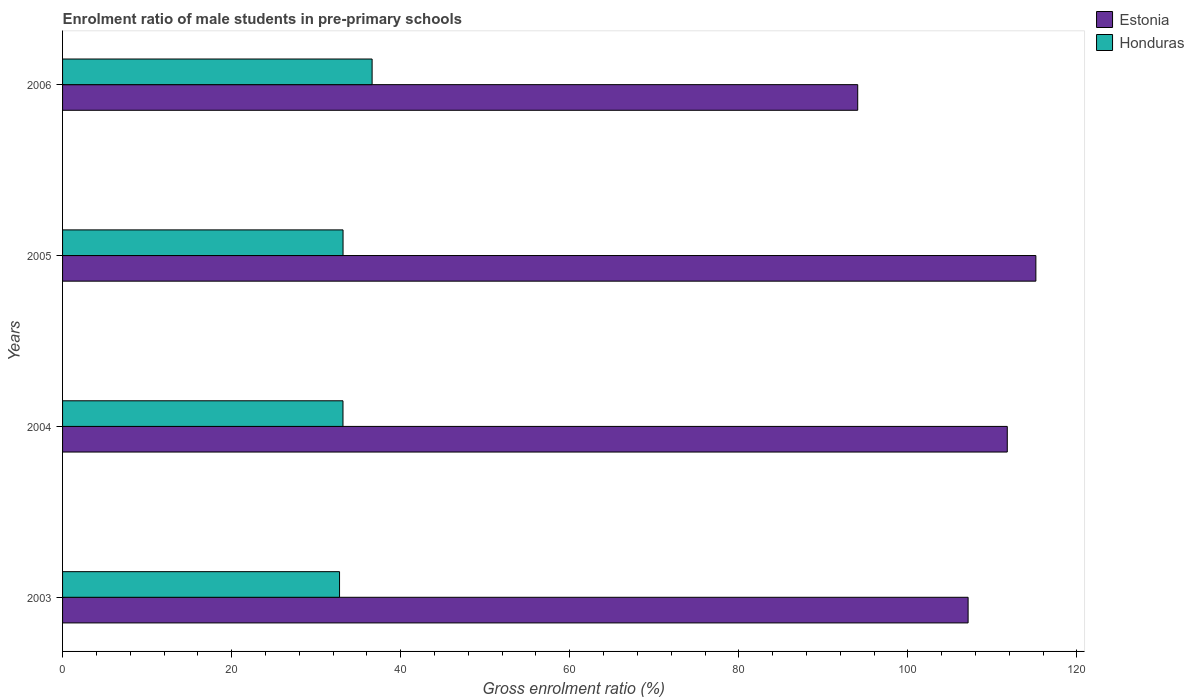How many bars are there on the 3rd tick from the top?
Offer a terse response. 2. What is the label of the 2nd group of bars from the top?
Your answer should be very brief. 2005. What is the enrolment ratio of male students in pre-primary schools in Honduras in 2003?
Make the answer very short. 32.77. Across all years, what is the maximum enrolment ratio of male students in pre-primary schools in Estonia?
Your answer should be compact. 115.14. Across all years, what is the minimum enrolment ratio of male students in pre-primary schools in Estonia?
Provide a succinct answer. 94.06. In which year was the enrolment ratio of male students in pre-primary schools in Honduras minimum?
Ensure brevity in your answer.  2003. What is the total enrolment ratio of male students in pre-primary schools in Estonia in the graph?
Your answer should be very brief. 428.08. What is the difference between the enrolment ratio of male students in pre-primary schools in Honduras in 2003 and that in 2006?
Provide a short and direct response. -3.85. What is the difference between the enrolment ratio of male students in pre-primary schools in Estonia in 2004 and the enrolment ratio of male students in pre-primary schools in Honduras in 2005?
Give a very brief answer. 78.58. What is the average enrolment ratio of male students in pre-primary schools in Estonia per year?
Your answer should be very brief. 107.02. In the year 2006, what is the difference between the enrolment ratio of male students in pre-primary schools in Estonia and enrolment ratio of male students in pre-primary schools in Honduras?
Your answer should be very brief. 57.45. In how many years, is the enrolment ratio of male students in pre-primary schools in Estonia greater than 52 %?
Keep it short and to the point. 4. What is the ratio of the enrolment ratio of male students in pre-primary schools in Estonia in 2005 to that in 2006?
Ensure brevity in your answer.  1.22. What is the difference between the highest and the second highest enrolment ratio of male students in pre-primary schools in Honduras?
Your answer should be very brief. 3.44. What is the difference between the highest and the lowest enrolment ratio of male students in pre-primary schools in Honduras?
Provide a succinct answer. 3.85. In how many years, is the enrolment ratio of male students in pre-primary schools in Honduras greater than the average enrolment ratio of male students in pre-primary schools in Honduras taken over all years?
Make the answer very short. 1. What does the 1st bar from the top in 2006 represents?
Your answer should be compact. Honduras. What does the 1st bar from the bottom in 2005 represents?
Keep it short and to the point. Estonia. How many bars are there?
Your answer should be very brief. 8. Are all the bars in the graph horizontal?
Give a very brief answer. Yes. How many years are there in the graph?
Give a very brief answer. 4. What is the difference between two consecutive major ticks on the X-axis?
Your answer should be compact. 20. Does the graph contain any zero values?
Provide a short and direct response. No. Does the graph contain grids?
Make the answer very short. No. How are the legend labels stacked?
Make the answer very short. Vertical. What is the title of the graph?
Offer a very short reply. Enrolment ratio of male students in pre-primary schools. Does "Antigua and Barbuda" appear as one of the legend labels in the graph?
Ensure brevity in your answer.  No. What is the Gross enrolment ratio (%) in Estonia in 2003?
Give a very brief answer. 107.12. What is the Gross enrolment ratio (%) in Honduras in 2003?
Your answer should be very brief. 32.77. What is the Gross enrolment ratio (%) in Estonia in 2004?
Offer a terse response. 111.76. What is the Gross enrolment ratio (%) of Honduras in 2004?
Offer a very short reply. 33.17. What is the Gross enrolment ratio (%) of Estonia in 2005?
Keep it short and to the point. 115.14. What is the Gross enrolment ratio (%) in Honduras in 2005?
Give a very brief answer. 33.18. What is the Gross enrolment ratio (%) of Estonia in 2006?
Offer a very short reply. 94.06. What is the Gross enrolment ratio (%) of Honduras in 2006?
Your response must be concise. 36.62. Across all years, what is the maximum Gross enrolment ratio (%) of Estonia?
Your answer should be very brief. 115.14. Across all years, what is the maximum Gross enrolment ratio (%) in Honduras?
Provide a short and direct response. 36.62. Across all years, what is the minimum Gross enrolment ratio (%) of Estonia?
Offer a terse response. 94.06. Across all years, what is the minimum Gross enrolment ratio (%) in Honduras?
Offer a terse response. 32.77. What is the total Gross enrolment ratio (%) of Estonia in the graph?
Make the answer very short. 428.08. What is the total Gross enrolment ratio (%) of Honduras in the graph?
Provide a short and direct response. 135.74. What is the difference between the Gross enrolment ratio (%) in Estonia in 2003 and that in 2004?
Keep it short and to the point. -4.63. What is the difference between the Gross enrolment ratio (%) of Honduras in 2003 and that in 2004?
Your answer should be very brief. -0.41. What is the difference between the Gross enrolment ratio (%) of Estonia in 2003 and that in 2005?
Provide a succinct answer. -8.02. What is the difference between the Gross enrolment ratio (%) in Honduras in 2003 and that in 2005?
Ensure brevity in your answer.  -0.41. What is the difference between the Gross enrolment ratio (%) in Estonia in 2003 and that in 2006?
Provide a succinct answer. 13.06. What is the difference between the Gross enrolment ratio (%) in Honduras in 2003 and that in 2006?
Keep it short and to the point. -3.85. What is the difference between the Gross enrolment ratio (%) of Estonia in 2004 and that in 2005?
Give a very brief answer. -3.38. What is the difference between the Gross enrolment ratio (%) of Honduras in 2004 and that in 2005?
Offer a terse response. -0.01. What is the difference between the Gross enrolment ratio (%) in Estonia in 2004 and that in 2006?
Provide a succinct answer. 17.69. What is the difference between the Gross enrolment ratio (%) of Honduras in 2004 and that in 2006?
Give a very brief answer. -3.45. What is the difference between the Gross enrolment ratio (%) in Estonia in 2005 and that in 2006?
Provide a succinct answer. 21.07. What is the difference between the Gross enrolment ratio (%) in Honduras in 2005 and that in 2006?
Keep it short and to the point. -3.44. What is the difference between the Gross enrolment ratio (%) of Estonia in 2003 and the Gross enrolment ratio (%) of Honduras in 2004?
Give a very brief answer. 73.95. What is the difference between the Gross enrolment ratio (%) of Estonia in 2003 and the Gross enrolment ratio (%) of Honduras in 2005?
Provide a succinct answer. 73.94. What is the difference between the Gross enrolment ratio (%) in Estonia in 2003 and the Gross enrolment ratio (%) in Honduras in 2006?
Your answer should be very brief. 70.5. What is the difference between the Gross enrolment ratio (%) of Estonia in 2004 and the Gross enrolment ratio (%) of Honduras in 2005?
Your answer should be very brief. 78.58. What is the difference between the Gross enrolment ratio (%) of Estonia in 2004 and the Gross enrolment ratio (%) of Honduras in 2006?
Provide a succinct answer. 75.14. What is the difference between the Gross enrolment ratio (%) of Estonia in 2005 and the Gross enrolment ratio (%) of Honduras in 2006?
Your answer should be compact. 78.52. What is the average Gross enrolment ratio (%) of Estonia per year?
Give a very brief answer. 107.02. What is the average Gross enrolment ratio (%) of Honduras per year?
Keep it short and to the point. 33.93. In the year 2003, what is the difference between the Gross enrolment ratio (%) in Estonia and Gross enrolment ratio (%) in Honduras?
Your answer should be compact. 74.36. In the year 2004, what is the difference between the Gross enrolment ratio (%) in Estonia and Gross enrolment ratio (%) in Honduras?
Your answer should be very brief. 78.58. In the year 2005, what is the difference between the Gross enrolment ratio (%) of Estonia and Gross enrolment ratio (%) of Honduras?
Provide a succinct answer. 81.96. In the year 2006, what is the difference between the Gross enrolment ratio (%) of Estonia and Gross enrolment ratio (%) of Honduras?
Your response must be concise. 57.45. What is the ratio of the Gross enrolment ratio (%) of Estonia in 2003 to that in 2004?
Your answer should be very brief. 0.96. What is the ratio of the Gross enrolment ratio (%) in Estonia in 2003 to that in 2005?
Your response must be concise. 0.93. What is the ratio of the Gross enrolment ratio (%) of Honduras in 2003 to that in 2005?
Offer a very short reply. 0.99. What is the ratio of the Gross enrolment ratio (%) of Estonia in 2003 to that in 2006?
Your response must be concise. 1.14. What is the ratio of the Gross enrolment ratio (%) in Honduras in 2003 to that in 2006?
Your response must be concise. 0.89. What is the ratio of the Gross enrolment ratio (%) of Estonia in 2004 to that in 2005?
Your answer should be compact. 0.97. What is the ratio of the Gross enrolment ratio (%) in Honduras in 2004 to that in 2005?
Offer a very short reply. 1. What is the ratio of the Gross enrolment ratio (%) in Estonia in 2004 to that in 2006?
Offer a terse response. 1.19. What is the ratio of the Gross enrolment ratio (%) of Honduras in 2004 to that in 2006?
Ensure brevity in your answer.  0.91. What is the ratio of the Gross enrolment ratio (%) of Estonia in 2005 to that in 2006?
Ensure brevity in your answer.  1.22. What is the ratio of the Gross enrolment ratio (%) of Honduras in 2005 to that in 2006?
Give a very brief answer. 0.91. What is the difference between the highest and the second highest Gross enrolment ratio (%) of Estonia?
Provide a short and direct response. 3.38. What is the difference between the highest and the second highest Gross enrolment ratio (%) in Honduras?
Offer a terse response. 3.44. What is the difference between the highest and the lowest Gross enrolment ratio (%) of Estonia?
Make the answer very short. 21.07. What is the difference between the highest and the lowest Gross enrolment ratio (%) in Honduras?
Offer a terse response. 3.85. 